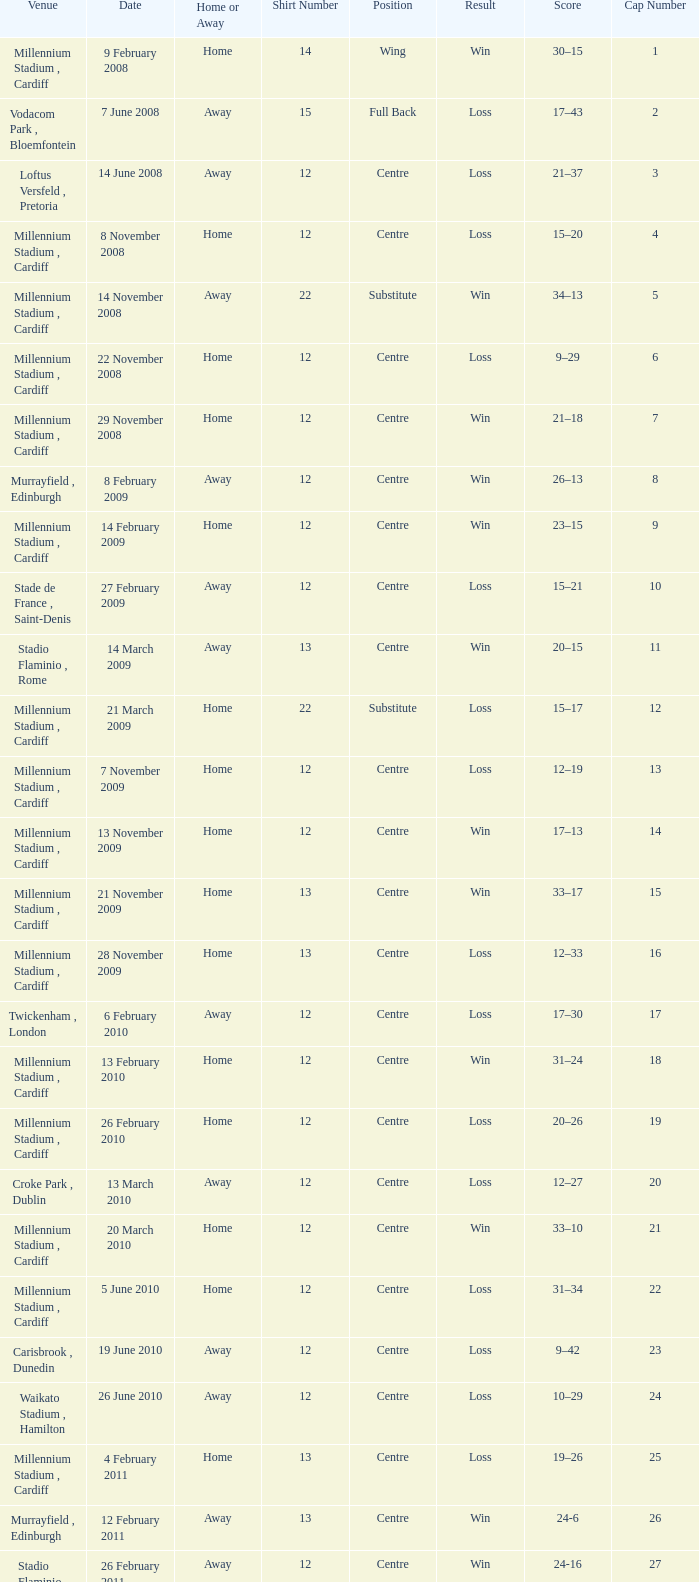What's the largest shirt number when the cap number is 5? 22.0. Could you help me parse every detail presented in this table? {'header': ['Venue', 'Date', 'Home or Away', 'Shirt Number', 'Position', 'Result', 'Score', 'Cap Number'], 'rows': [['Millennium Stadium , Cardiff', '9 February 2008', 'Home', '14', 'Wing', 'Win', '30–15', '1'], ['Vodacom Park , Bloemfontein', '7 June 2008', 'Away', '15', 'Full Back', 'Loss', '17–43', '2'], ['Loftus Versfeld , Pretoria', '14 June 2008', 'Away', '12', 'Centre', 'Loss', '21–37', '3'], ['Millennium Stadium , Cardiff', '8 November 2008', 'Home', '12', 'Centre', 'Loss', '15–20', '4'], ['Millennium Stadium , Cardiff', '14 November 2008', 'Away', '22', 'Substitute', 'Win', '34–13', '5'], ['Millennium Stadium , Cardiff', '22 November 2008', 'Home', '12', 'Centre', 'Loss', '9–29', '6'], ['Millennium Stadium , Cardiff', '29 November 2008', 'Home', '12', 'Centre', 'Win', '21–18', '7'], ['Murrayfield , Edinburgh', '8 February 2009', 'Away', '12', 'Centre', 'Win', '26–13', '8'], ['Millennium Stadium , Cardiff', '14 February 2009', 'Home', '12', 'Centre', 'Win', '23–15', '9'], ['Stade de France , Saint-Denis', '27 February 2009', 'Away', '12', 'Centre', 'Loss', '15–21', '10'], ['Stadio Flaminio , Rome', '14 March 2009', 'Away', '13', 'Centre', 'Win', '20–15', '11'], ['Millennium Stadium , Cardiff', '21 March 2009', 'Home', '22', 'Substitute', 'Loss', '15–17', '12'], ['Millennium Stadium , Cardiff', '7 November 2009', 'Home', '12', 'Centre', 'Loss', '12–19', '13'], ['Millennium Stadium , Cardiff', '13 November 2009', 'Home', '12', 'Centre', 'Win', '17–13', '14'], ['Millennium Stadium , Cardiff', '21 November 2009', 'Home', '13', 'Centre', 'Win', '33–17', '15'], ['Millennium Stadium , Cardiff', '28 November 2009', 'Home', '13', 'Centre', 'Loss', '12–33', '16'], ['Twickenham , London', '6 February 2010', 'Away', '12', 'Centre', 'Loss', '17–30', '17'], ['Millennium Stadium , Cardiff', '13 February 2010', 'Home', '12', 'Centre', 'Win', '31–24', '18'], ['Millennium Stadium , Cardiff', '26 February 2010', 'Home', '12', 'Centre', 'Loss', '20–26', '19'], ['Croke Park , Dublin', '13 March 2010', 'Away', '12', 'Centre', 'Loss', '12–27', '20'], ['Millennium Stadium , Cardiff', '20 March 2010', 'Home', '12', 'Centre', 'Win', '33–10', '21'], ['Millennium Stadium , Cardiff', '5 June 2010', 'Home', '12', 'Centre', 'Loss', '31–34', '22'], ['Carisbrook , Dunedin', '19 June 2010', 'Away', '12', 'Centre', 'Loss', '9–42', '23'], ['Waikato Stadium , Hamilton', '26 June 2010', 'Away', '12', 'Centre', 'Loss', '10–29', '24'], ['Millennium Stadium , Cardiff', '4 February 2011', 'Home', '13', 'Centre', 'Loss', '19–26', '25'], ['Murrayfield , Edinburgh', '12 February 2011', 'Away', '13', 'Centre', 'Win', '24-6', '26'], ['Stadio Flaminio , Rome', '26 February 2011', 'Away', '12', 'Centre', 'Win', '24-16', '27'], ['Millennium Stadium , Cardiff', '12 March 2011', 'Home', '13', 'Centre', 'Win', '19-13', '28'], ['Stade de France , Saint-Denis', '19 March 2011', 'Away', '13', 'Centre', 'Loss', '9-28', '29'], ['Twickenham , London', '6 August 2011', 'Away', '12', 'Centre', 'Loss', '19-23', '30'], ['Millennium Stadium , Cardiff', '13 August 2011', 'Home', '13', 'Centre', 'Win', '19-9', '31'], ['Millennium Stadium , Cardiff', '20 August 2011', 'Home', '12', 'Centre', 'Win', '28-13', '32'], ['Westpac Stadium , Wellington', '11 September 2011', 'Rugby World Cup', '12', 'Centre', 'Loss', '16-17', '33'], ['Waikato Stadium , Hamilton', '18 September 2011', 'Rugby World Cup', '12', 'Centre', 'Win', '17-10', '34'], ['Waikato Stadium , Hamilton', '2 September 2011', 'Rugby World Cup', '12', 'Centre', 'Win', '66-0', '35'], ['Westpac Stadium , Wellington', '8 October 2011', 'Rugby World Cup', '12', 'Centre', 'Win', '22-10', '36'], ['Eden Park , Auckland', '15 October 2011', 'Rugby World Cup', '12', 'Centre', 'Loss', '8-9', '37'], ['Eden Park , Auckland', '21 October 2011', 'Rugby World Cup', '12', 'Centre', 'Loss', '18-21', '38'], ['Millennium Stadium , Cardiff', '3 December 2011', 'Home', '12', 'Centre', 'Loss', '18-24', '39'], ['Aviva Stadium , Dublin', '5 February 2012', 'Away', '12', 'Centre', 'Win', '23-21', '40'], ['Millennium Stadium , Cardiff', '12 February 2012', 'Home', '12', 'Centre', 'Win', '27-13', '41'], ['Twickenham , London', '25 February 2012', 'Away', '12', 'Centre', 'Win', '19-12', '42'], ['Millennium Stadium , Cardiff', '9 March 2012', 'Home', '12', 'Centre', 'Win', '24-3', '43'], ['Millennium Stadium , Cardiff', '16 March 2012', 'Home', '12', 'Centre', 'Win', '16-9', '44'], ['Millennium Stadium , Cardiff', '10 November 2012', 'Home', '12', 'Centre', 'Loss', '12-26', '45'], ['Millennium Stadium , Cardiff', '16 November 2012', 'Home', '12', 'Centre', 'Loss', '19-26', '46'], ['Millennium Stadium , Cardiff', '24 November 2012', 'Home', '12', 'Centre', 'Loss', '10-33', '47'], ['Millennium Stadium , Cardiff', '1 December 2012', 'Home', '12', 'Centre', 'Loss', '12-14', '48'], ['Millennium Stadium , Cardiff', '2 February', 'Home', '12', 'Centre', 'Loss', '22-30', '49'], ['Stade de France , Paris', '9 February', 'Home', '12', 'Centre', 'Win', '16-6', '50']]} 